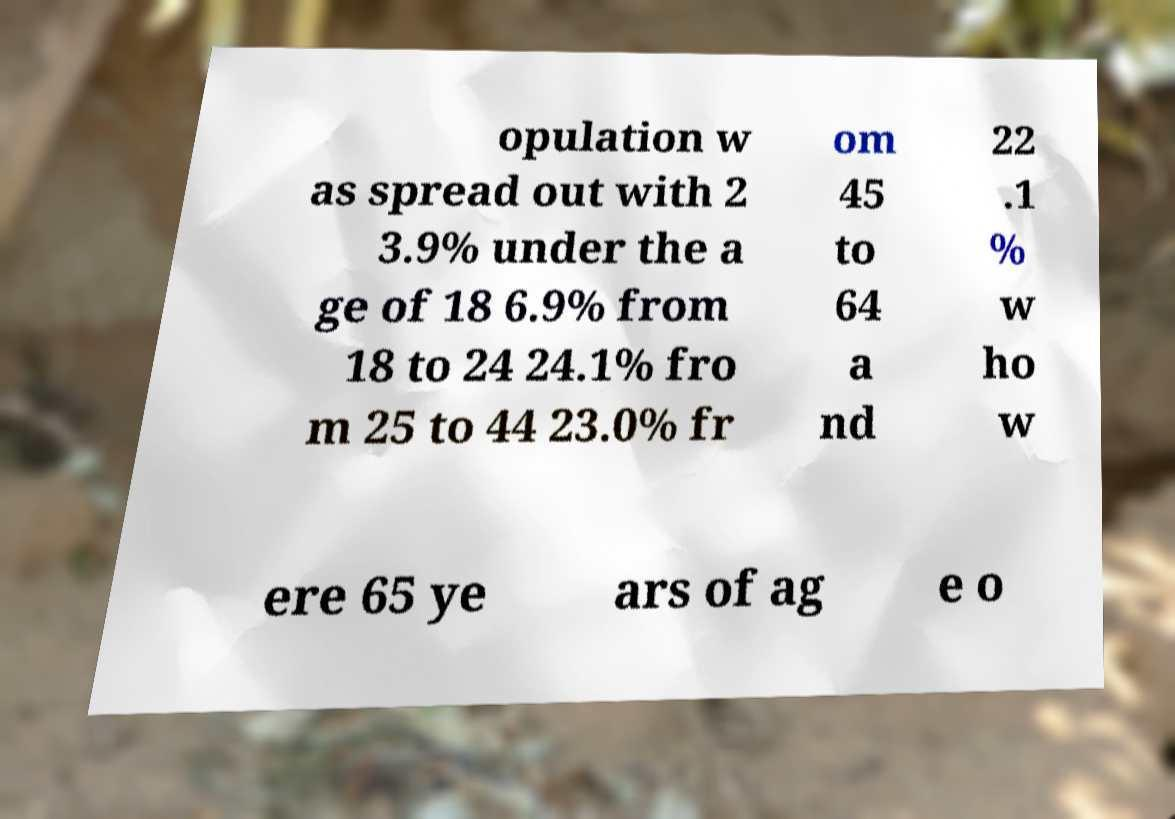Can you accurately transcribe the text from the provided image for me? opulation w as spread out with 2 3.9% under the a ge of 18 6.9% from 18 to 24 24.1% fro m 25 to 44 23.0% fr om 45 to 64 a nd 22 .1 % w ho w ere 65 ye ars of ag e o 